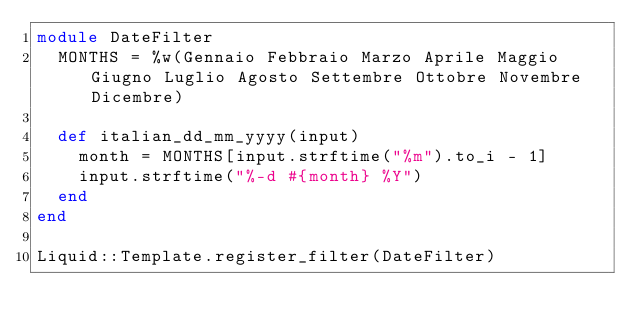<code> <loc_0><loc_0><loc_500><loc_500><_Ruby_>module DateFilter
  MONTHS = %w(Gennaio Febbraio Marzo Aprile Maggio Giugno Luglio Agosto Settembre Ottobre Novembre Dicembre)

  def italian_dd_mm_yyyy(input)
    month = MONTHS[input.strftime("%m").to_i - 1]
    input.strftime("%-d #{month} %Y")    
  end
end

Liquid::Template.register_filter(DateFilter)</code> 